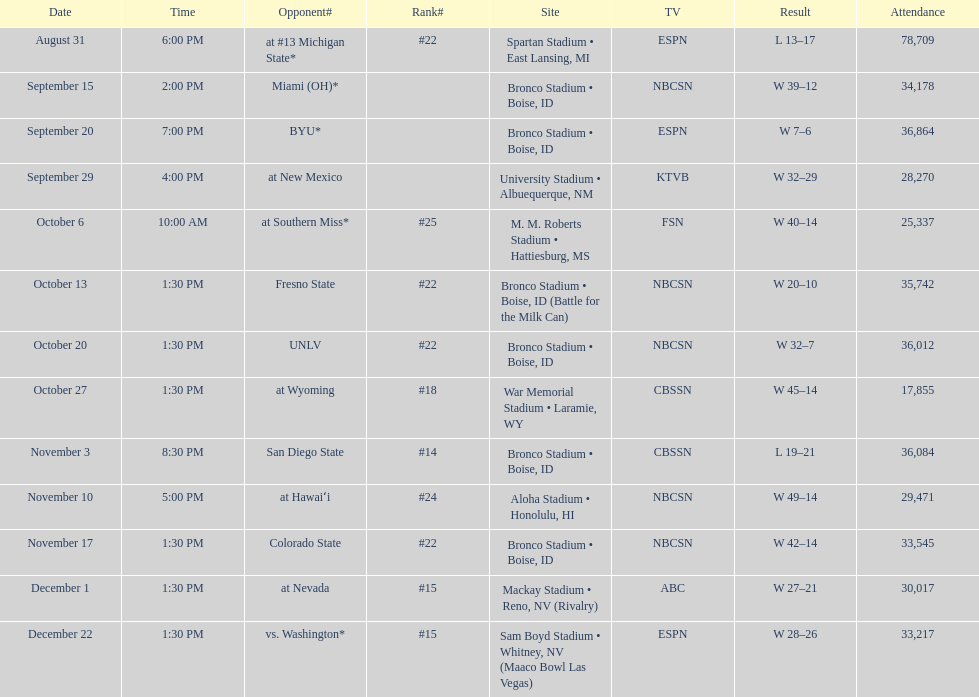What is the total number of games played at bronco stadium? 6. 